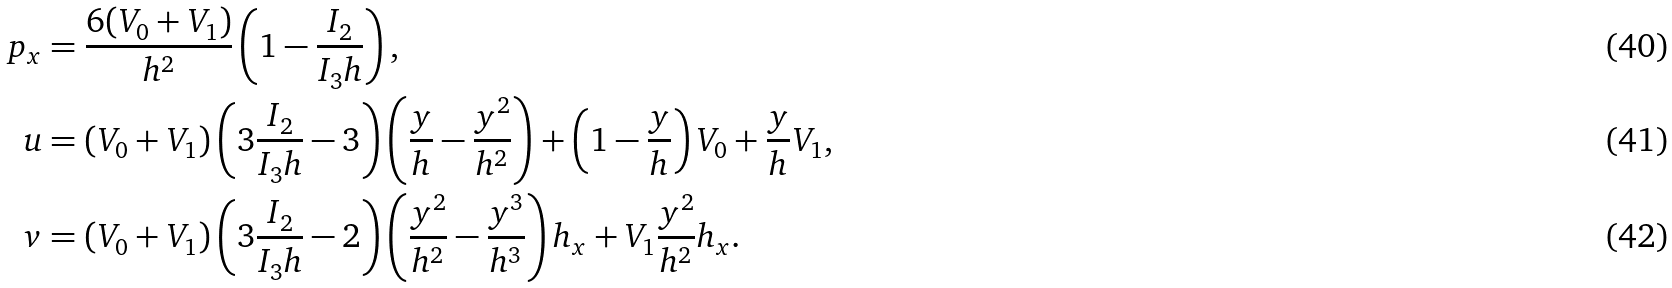<formula> <loc_0><loc_0><loc_500><loc_500>p _ { x } & = \frac { 6 ( V _ { 0 } + V _ { 1 } ) } { h ^ { 2 } } \left ( 1 - \frac { I _ { 2 } } { I _ { 3 } h } \right ) , \\ u & = ( V _ { 0 } + V _ { 1 } ) \left ( 3 \frac { I _ { 2 } } { I _ { 3 } h } - 3 \right ) \left ( \frac { y } { h } - \frac { y ^ { 2 } } { h ^ { 2 } } \right ) + \left ( 1 - \frac { y } { h } \right ) V _ { 0 } + \frac { y } { h } V _ { 1 } , \\ v & = ( V _ { 0 } + V _ { 1 } ) \left ( 3 \frac { I _ { 2 } } { I _ { 3 } h } - 2 \right ) \left ( \frac { y ^ { 2 } } { h ^ { 2 } } - \frac { y ^ { 3 } } { h ^ { 3 } } \right ) h _ { x } + V _ { 1 } \frac { y ^ { 2 } } { h ^ { 2 } } h _ { x } .</formula> 